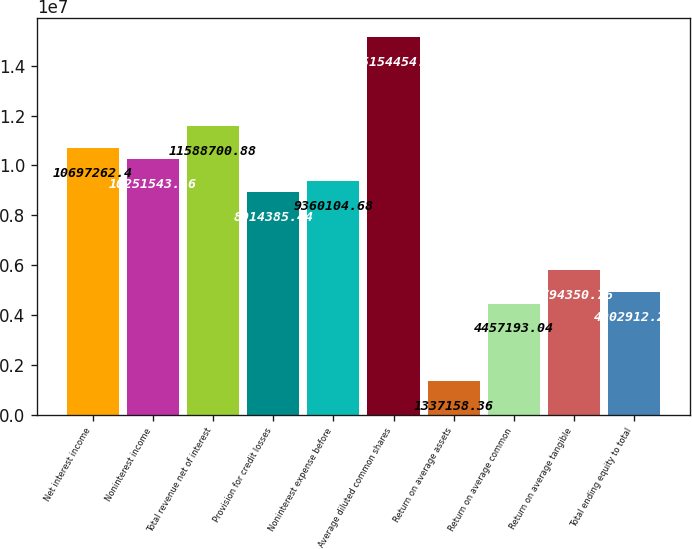<chart> <loc_0><loc_0><loc_500><loc_500><bar_chart><fcel>Net interest income<fcel>Noninterest income<fcel>Total revenue net of interest<fcel>Provision for credit losses<fcel>Noninterest expense before<fcel>Average diluted common shares<fcel>Return on average assets<fcel>Return on average common<fcel>Return on average tangible<fcel>Total ending equity to total<nl><fcel>1.06973e+07<fcel>1.02515e+07<fcel>1.15887e+07<fcel>8.91439e+06<fcel>9.3601e+06<fcel>1.51545e+07<fcel>1.33716e+06<fcel>4.45719e+06<fcel>5.79435e+06<fcel>4.90291e+06<nl></chart> 